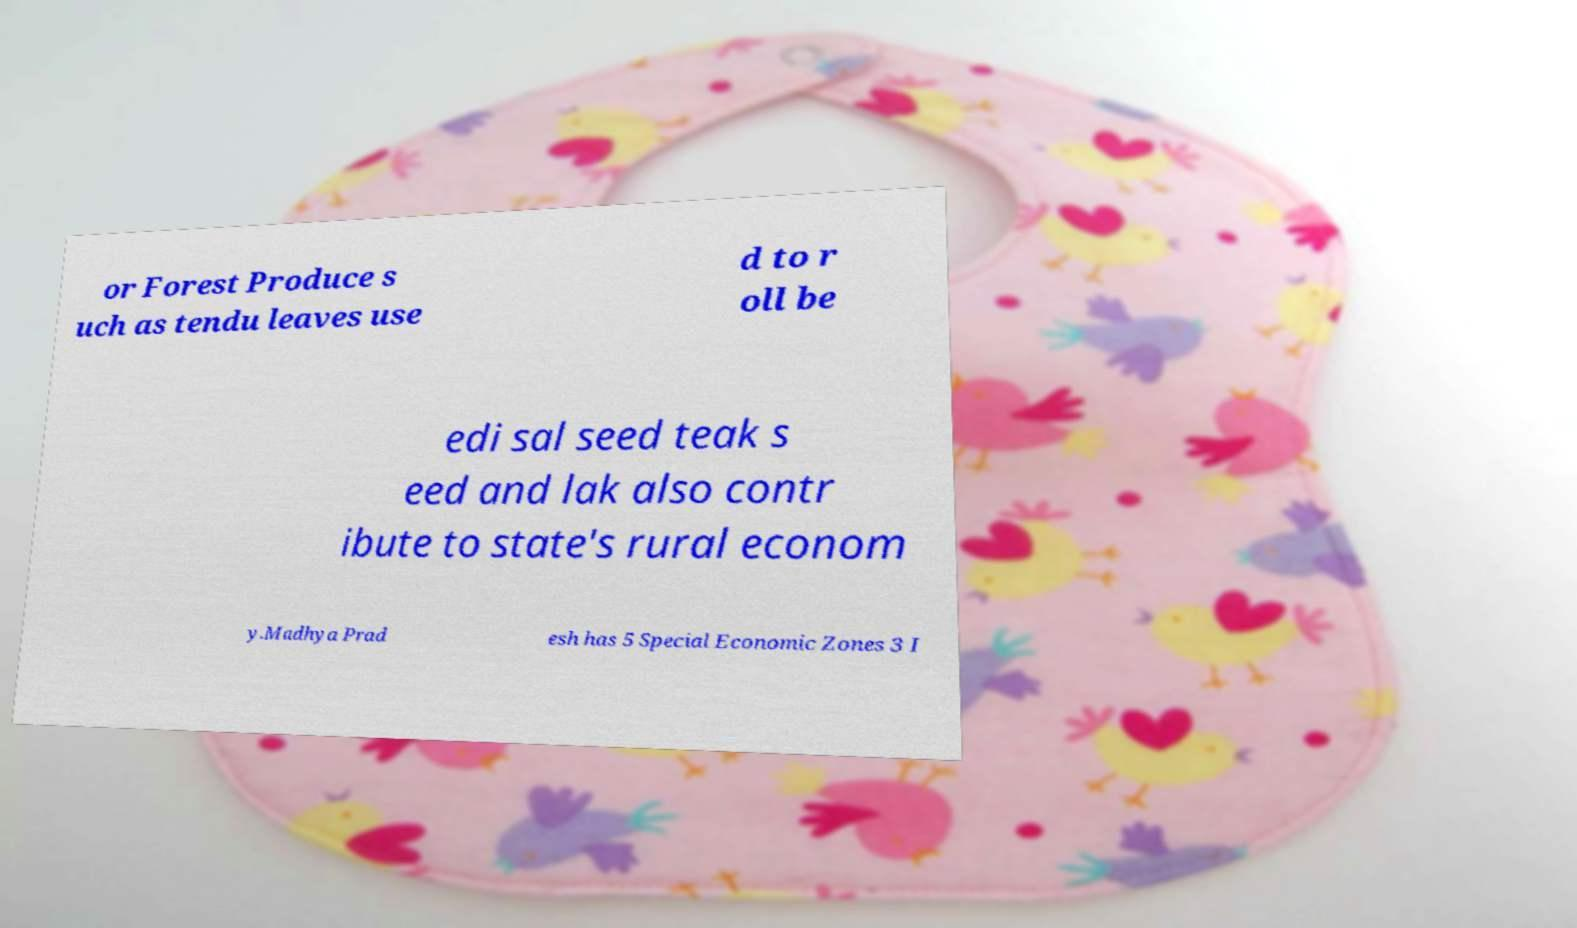Can you accurately transcribe the text from the provided image for me? or Forest Produce s uch as tendu leaves use d to r oll be edi sal seed teak s eed and lak also contr ibute to state's rural econom y.Madhya Prad esh has 5 Special Economic Zones 3 I 